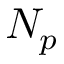Convert formula to latex. <formula><loc_0><loc_0><loc_500><loc_500>N _ { p }</formula> 